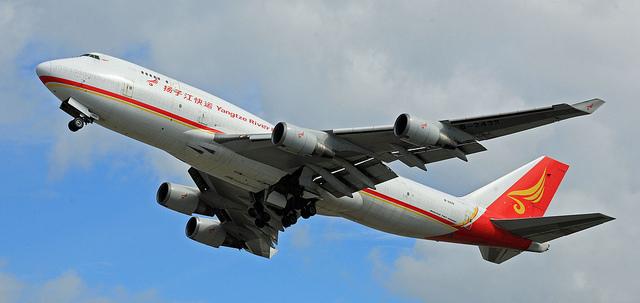Is this plane taking off?
Quick response, please. Yes. How many jets does the plane have?
Answer briefly. 4. Is this a big plane?
Be succinct. Yes. 